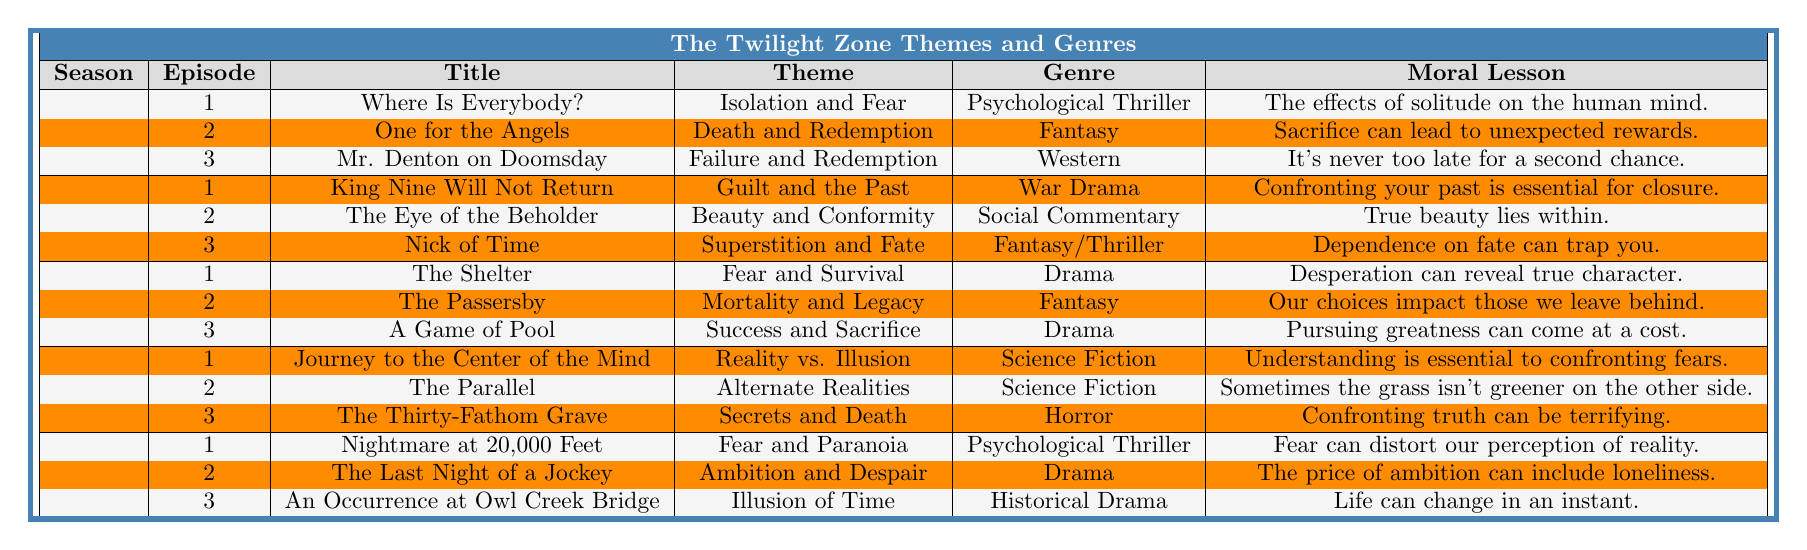What is the theme of the episode "The Eye of the Beholder"? Referring to the table, the episode "The Eye of the Beholder" is listed under Season 2, Episode 2, and its theme is "Beauty and Conformity."
Answer: Beauty and Conformity In which genre does the episode "An Occurrence at Owl Creek Bridge" fall? Looking at the table, "An Occurrence at Owl Creek Bridge" is from Season 5, Episode 3, and it is categorized under the genre "Historical Drama."
Answer: Historical Drama What are the moral lessons associated with the first episode of Season 3? The first episode in Season 3 is "The Shelter," and according to the table, the moral lesson is "Desperation can reveal true character."
Answer: Desperation can reveal true character How many episodes in Season 4 have a theme related to reality or perception? From the table, Season 4 has three episodes. "Journey to the Center of the Mind" (Reality vs. Illusion) and "The Parallel" (Alternate Realities) are related to reality or perception, making it two episodes.
Answer: 2 Which season contains the most episodes with a theme of fear? Reviewing the table, Season 1 has an episode titled "Where Is Everybody?" with a theme of "Isolation and Fear," Season 3 has "The Shelter" (Fear and Survival), and Season 5 includes "Nightmare at 20,000 Feet" (Fear and Paranoia). Therefore, that totals three episodes across Seasons 1, 3, and 5. However, with respect to just one season, Season 5 has the greatest focus on fear as it contains two episodes.
Answer: Season 5 What is the common theme among the episodes in Season 2? Upon examining the table, the episodes in Season 2 feature distinct themes: “Guilt and the Past,” “Beauty and Conformity,” and “Superstition and Fate.” Therefore, there isn't a common overarching theme among them.
Answer: No common theme Which moral lesson from Season 1 reflects a key trait of human experience? The moral lesson from "One for the Angels," the second episode in Season 1, states: "Sacrifice can lead to unexpected rewards." This relates deeply to human experience by emphasizing altruistic behavior and its unanticipated benefits.
Answer: Sacrifice can lead to unexpected rewards Which episode shows a theme of legacy and its impact? The table indicates that "The Passersby" from Season 3 deals with the theme “Mortality and Legacy.”
Answer: The Passersby Is the theme of "Success and Sacrifice" present in more than one season? Reviewing the table, the theme "Success and Sacrifice" appears only in "A Game of Pool" from Season 3, meaning it does not occur in any other season.
Answer: No What are the genres of the episodes that highlight themes of death? From the table, "One for the Angels" (Fantasy) and "The Thirty-Fathom Grave" (Horror) both highlight themes of death in their respective episodes.
Answer: Fantasy and Horror 